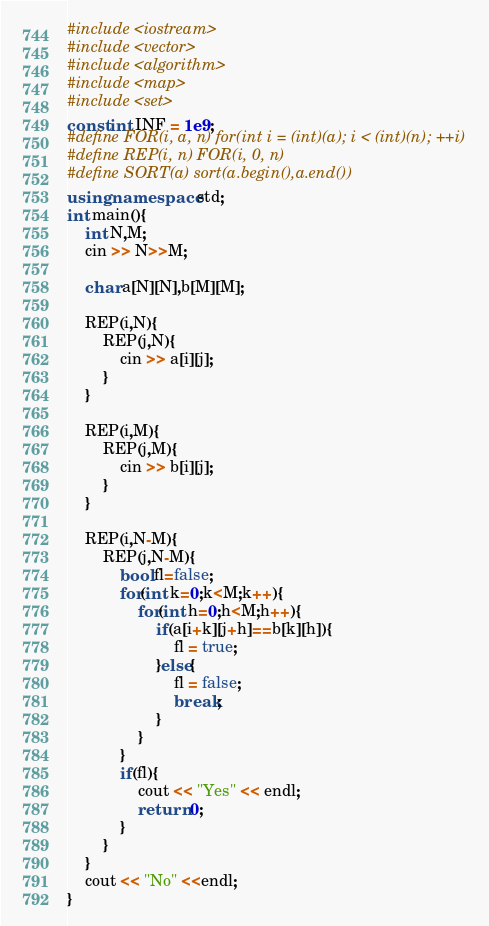<code> <loc_0><loc_0><loc_500><loc_500><_C++_>#include <iostream>
#include <vector>
#include <algorithm>
#include <map>
#include <set>
const int INF = 1e9;
#define FOR(i, a, n) for(int i = (int)(a); i < (int)(n); ++i)
#define REP(i, n) FOR(i, 0, n)
#define SORT(a) sort(a.begin(),a.end())
using namespace std;
int main(){
    int N,M;
    cin >> N>>M;

    char a[N][N],b[M][M];

    REP(i,N){
        REP(j,N){
            cin >> a[i][j];
        }
    }

    REP(i,M){
        REP(j,M){
            cin >> b[i][j];
        }
    }

    REP(i,N-M){
        REP(j,N-M){
            bool fl=false;
            for(int k=0;k<M;k++){
                for(int h=0;h<M;h++){
                    if(a[i+k][j+h]==b[k][h]){
                        fl = true;
                    }else{
                        fl = false;
                        break;
                    }
                }
            }
            if(fl){
                cout << "Yes" << endl;
                return 0;
            }
        }
    }
    cout << "No" <<endl;
}</code> 